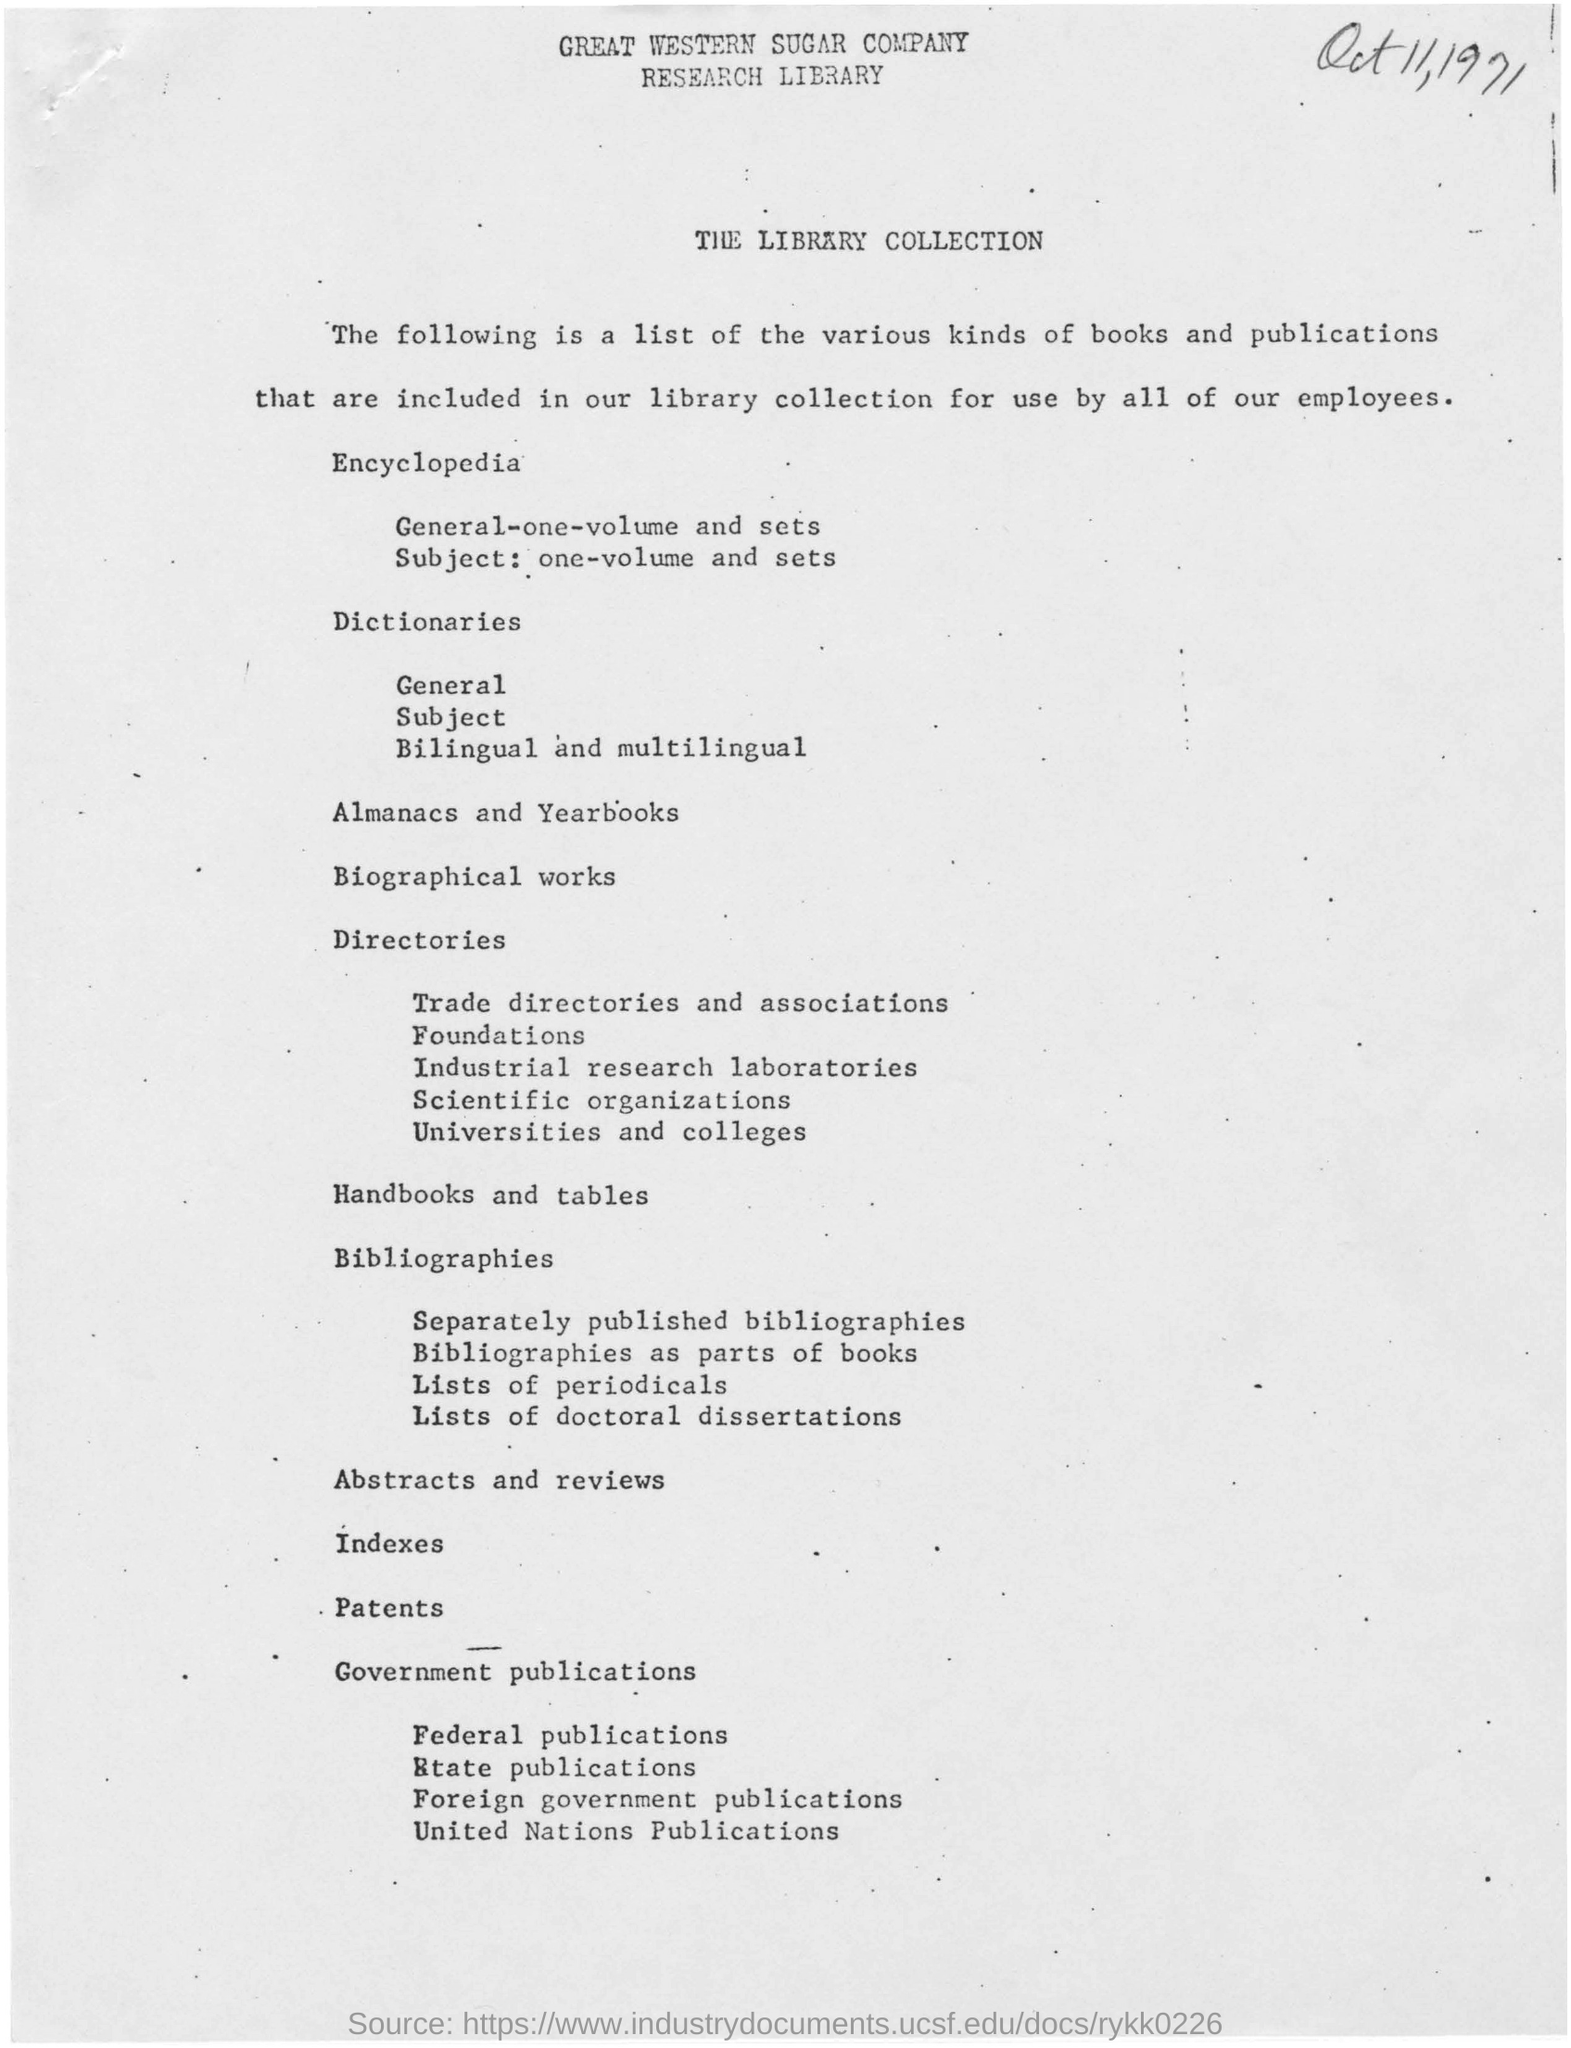Highlight a few significant elements in this photo. The books and publications in our library collection are intended for the use of all of our employees. Our library collection includes a diverse range of books and publications that are available for use by all employees. The document is from the Great Western Sugar Company. 